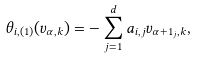<formula> <loc_0><loc_0><loc_500><loc_500>\theta _ { i , ( 1 ) } ( v _ { \alpha , k } ) = - \sum _ { j = 1 } ^ { d } a _ { i , j } v _ { \alpha + 1 _ { j } , k } ,</formula> 